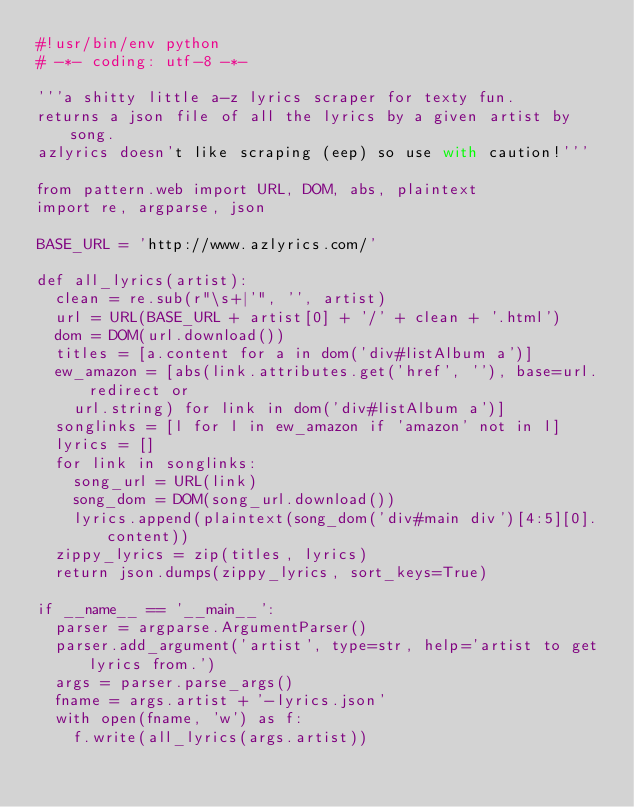Convert code to text. <code><loc_0><loc_0><loc_500><loc_500><_Python_>#!usr/bin/env python
# -*- coding: utf-8 -*-

'''a shitty little a-z lyrics scraper for texty fun.
returns a json file of all the lyrics by a given artist by song.
azlyrics doesn't like scraping (eep) so use with caution!'''

from pattern.web import URL, DOM, abs, plaintext
import re, argparse, json

BASE_URL = 'http://www.azlyrics.com/'

def all_lyrics(artist):
	clean = re.sub(r"\s+|'", '', artist)
	url = URL(BASE_URL + artist[0] + '/' + clean + '.html')
	dom = DOM(url.download())
	titles = [a.content for a in dom('div#listAlbum a')]
	ew_amazon = [abs(link.attributes.get('href', ''), base=url.redirect or
		url.string) for link in dom('div#listAlbum a')]
	songlinks = [l for l in ew_amazon if 'amazon' not in l]
	lyrics = []
	for link in songlinks:
		song_url = URL(link)
		song_dom = DOM(song_url.download())
		lyrics.append(plaintext(song_dom('div#main div')[4:5][0].content))
	zippy_lyrics = zip(titles, lyrics)
	return json.dumps(zippy_lyrics, sort_keys=True)

if __name__ == '__main__':
	parser = argparse.ArgumentParser()
	parser.add_argument('artist', type=str, help='artist to get lyrics from.')
	args = parser.parse_args()
	fname = args.artist + '-lyrics.json'
	with open(fname, 'w') as f:
		f.write(all_lyrics(args.artist))
</code> 